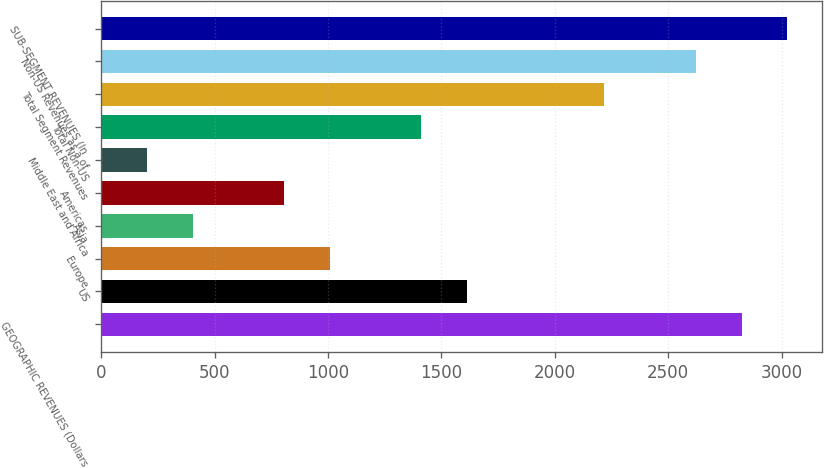Convert chart to OTSL. <chart><loc_0><loc_0><loc_500><loc_500><bar_chart><fcel>GEOGRAPHIC REVENUES (Dollars<fcel>US<fcel>Europe<fcel>Asia<fcel>Americas<fcel>Middle East and Africa<fcel>Total Non-US<fcel>Total Segment Revenues<fcel>Non-US Revenues as a of<fcel>SUB-SEGMENT REVENUES (In<nl><fcel>2823.68<fcel>1613.66<fcel>1008.65<fcel>403.64<fcel>806.98<fcel>201.97<fcel>1411.99<fcel>2218.67<fcel>2622.01<fcel>3025.35<nl></chart> 